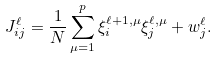<formula> <loc_0><loc_0><loc_500><loc_500>J _ { i j } ^ { \ell } = \frac { 1 } { N } \sum _ { \mu = 1 } ^ { p } \xi _ { i } ^ { \ell + 1 , \mu } \xi _ { j } ^ { \ell , \mu } + w _ { j } ^ { \ell } .</formula> 